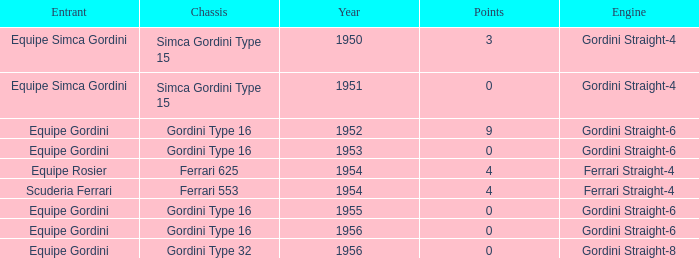What engine was used by Equipe Simca Gordini before 1956 with less than 4 points? Gordini Straight-4, Gordini Straight-4. 